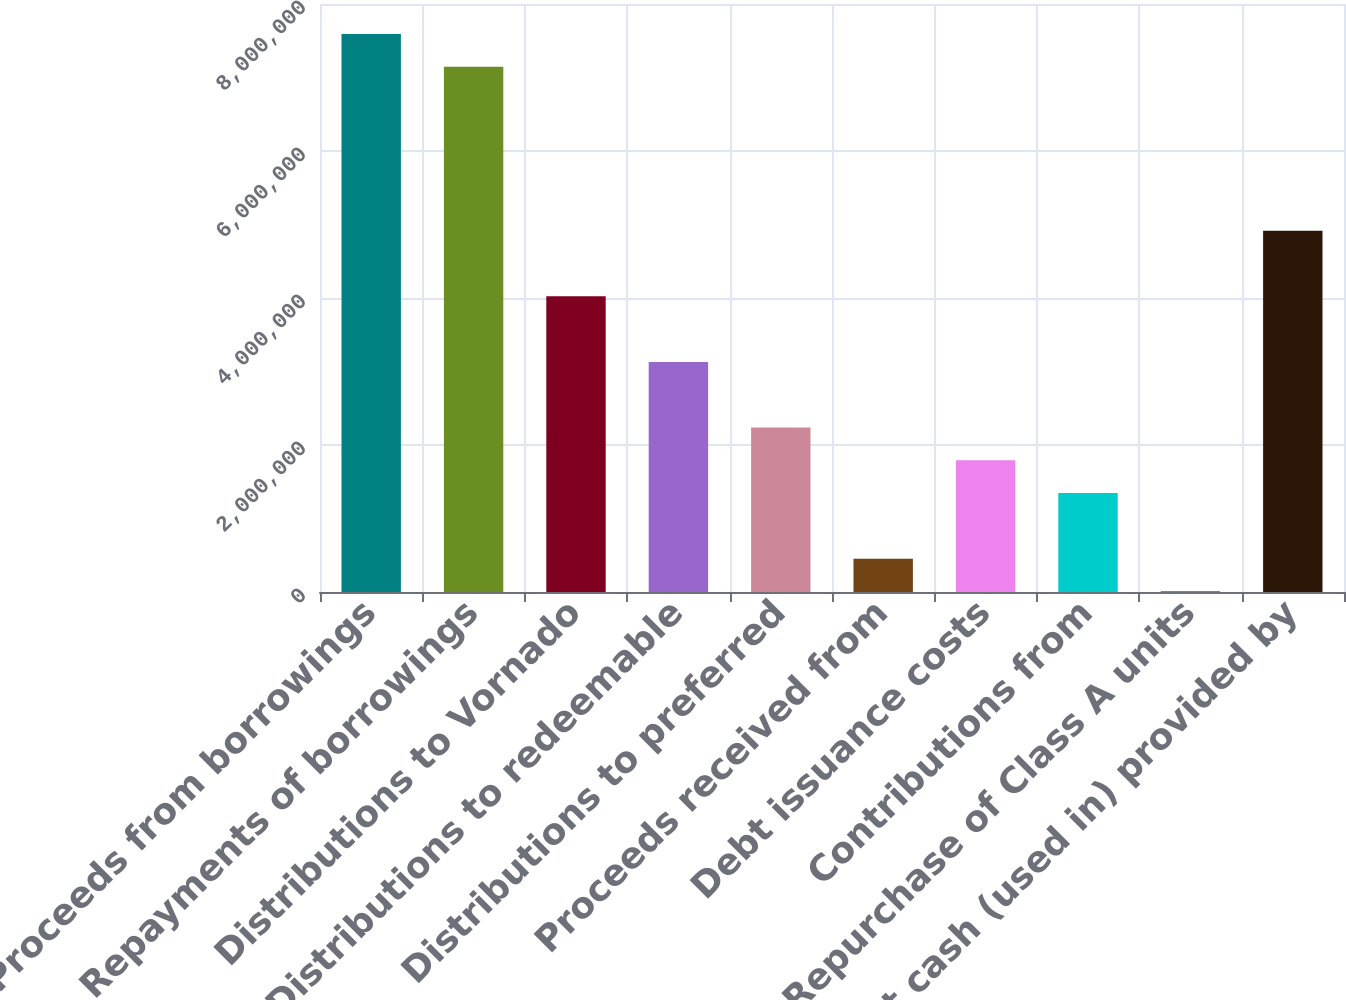<chart> <loc_0><loc_0><loc_500><loc_500><bar_chart><fcel>Proceeds from borrowings<fcel>Repayments of borrowings<fcel>Distributions to Vornado<fcel>Distributions to redeemable<fcel>Distributions to preferred<fcel>Proceeds received from<fcel>Debt issuance costs<fcel>Contributions from<fcel>Repurchase of Class A units<fcel>Net cash (used in) provided by<nl><fcel>7.59185e+06<fcel>7.14571e+06<fcel>4.02273e+06<fcel>3.13045e+06<fcel>2.23817e+06<fcel>453613<fcel>1.79203e+06<fcel>1.34589e+06<fcel>7473<fcel>4.91501e+06<nl></chart> 